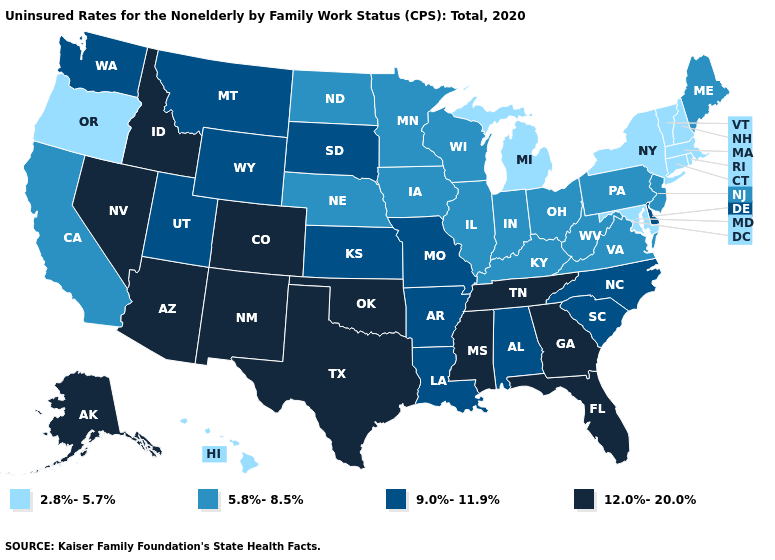What is the value of Louisiana?
Short answer required. 9.0%-11.9%. What is the highest value in states that border Pennsylvania?
Keep it brief. 9.0%-11.9%. Among the states that border California , which have the highest value?
Give a very brief answer. Arizona, Nevada. What is the value of Iowa?
Answer briefly. 5.8%-8.5%. What is the highest value in the South ?
Quick response, please. 12.0%-20.0%. Is the legend a continuous bar?
Write a very short answer. No. Name the states that have a value in the range 9.0%-11.9%?
Quick response, please. Alabama, Arkansas, Delaware, Kansas, Louisiana, Missouri, Montana, North Carolina, South Carolina, South Dakota, Utah, Washington, Wyoming. Does Kansas have the highest value in the MidWest?
Write a very short answer. Yes. Name the states that have a value in the range 5.8%-8.5%?
Keep it brief. California, Illinois, Indiana, Iowa, Kentucky, Maine, Minnesota, Nebraska, New Jersey, North Dakota, Ohio, Pennsylvania, Virginia, West Virginia, Wisconsin. What is the highest value in states that border South Dakota?
Short answer required. 9.0%-11.9%. How many symbols are there in the legend?
Answer briefly. 4. How many symbols are there in the legend?
Give a very brief answer. 4. What is the value of Texas?
Answer briefly. 12.0%-20.0%. What is the value of Minnesota?
Answer briefly. 5.8%-8.5%. 